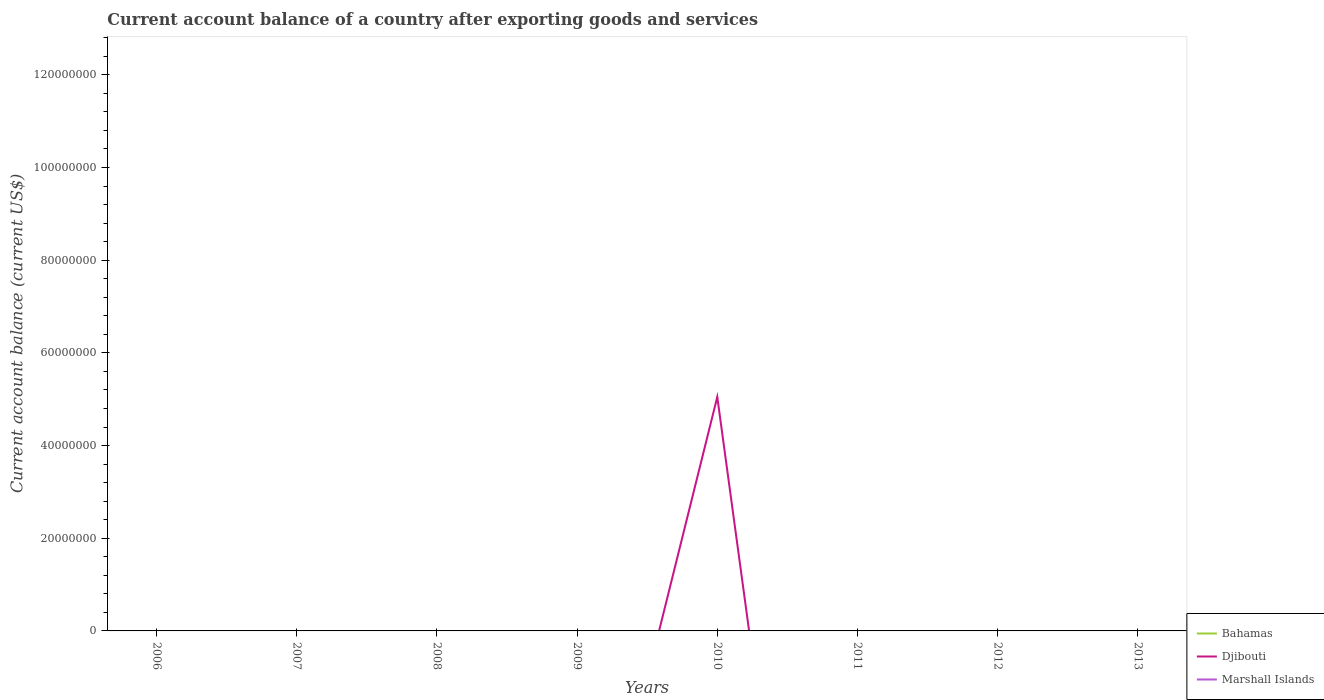How many different coloured lines are there?
Your answer should be very brief. 1. What is the difference between the highest and the second highest account balance in Djibouti?
Provide a succinct answer. 5.05e+07. What is the difference between the highest and the lowest account balance in Bahamas?
Give a very brief answer. 0. Is the account balance in Marshall Islands strictly greater than the account balance in Bahamas over the years?
Provide a succinct answer. No. How many years are there in the graph?
Your answer should be very brief. 8. How many legend labels are there?
Make the answer very short. 3. How are the legend labels stacked?
Your answer should be compact. Vertical. What is the title of the graph?
Your response must be concise. Current account balance of a country after exporting goods and services. What is the label or title of the X-axis?
Offer a terse response. Years. What is the label or title of the Y-axis?
Provide a short and direct response. Current account balance (current US$). What is the Current account balance (current US$) in Bahamas in 2006?
Give a very brief answer. 0. What is the Current account balance (current US$) in Djibouti in 2006?
Provide a succinct answer. 0. What is the Current account balance (current US$) in Djibouti in 2007?
Your response must be concise. 0. What is the Current account balance (current US$) of Marshall Islands in 2007?
Your response must be concise. 0. What is the Current account balance (current US$) of Bahamas in 2009?
Your response must be concise. 0. What is the Current account balance (current US$) of Marshall Islands in 2009?
Give a very brief answer. 0. What is the Current account balance (current US$) in Djibouti in 2010?
Your response must be concise. 5.05e+07. What is the Current account balance (current US$) in Marshall Islands in 2010?
Keep it short and to the point. 0. What is the Current account balance (current US$) in Djibouti in 2011?
Keep it short and to the point. 0. What is the Current account balance (current US$) of Marshall Islands in 2012?
Your response must be concise. 0. What is the Current account balance (current US$) in Djibouti in 2013?
Provide a succinct answer. 0. Across all years, what is the maximum Current account balance (current US$) in Djibouti?
Give a very brief answer. 5.05e+07. Across all years, what is the minimum Current account balance (current US$) in Djibouti?
Offer a terse response. 0. What is the total Current account balance (current US$) in Djibouti in the graph?
Offer a terse response. 5.05e+07. What is the average Current account balance (current US$) in Djibouti per year?
Provide a succinct answer. 6.31e+06. What is the average Current account balance (current US$) of Marshall Islands per year?
Your response must be concise. 0. What is the difference between the highest and the lowest Current account balance (current US$) in Djibouti?
Your response must be concise. 5.05e+07. 